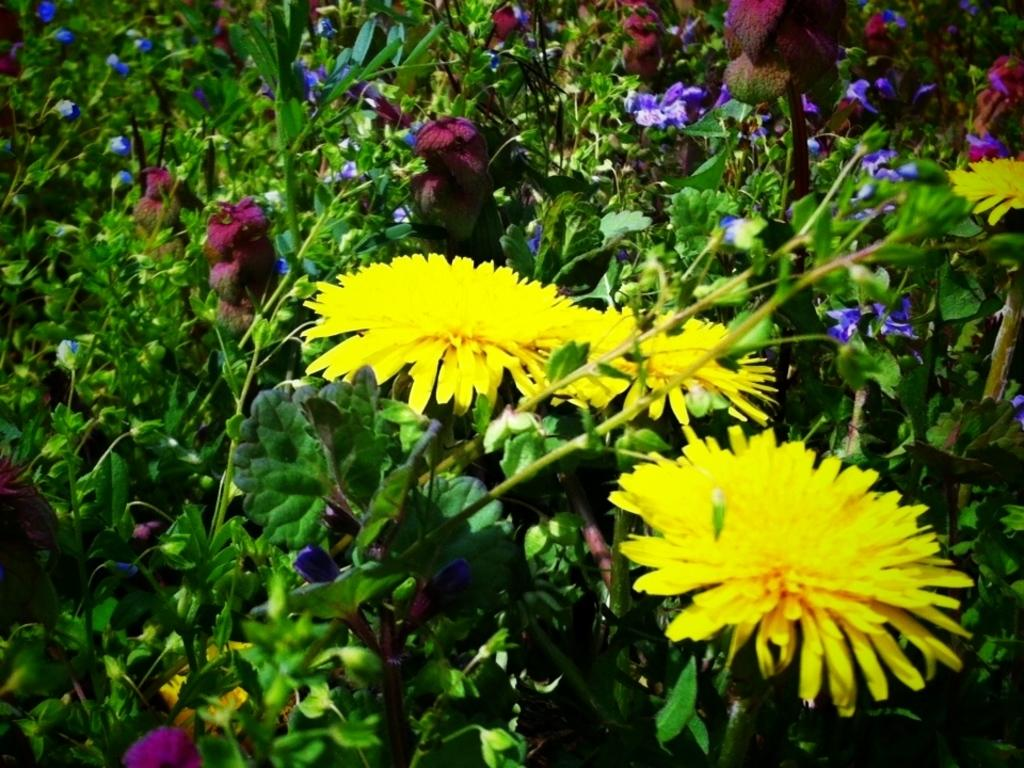What colors of flowers can be seen in the image? There are yellow, blue, and maroon flowers in the image. Can you describe the variety of flowers in the image? The image features yellow, blue, and maroon flowers. Is there a snail crawling on the maroon flowers in the image? There is no snail present in the image; it only features flowers of different colors. 